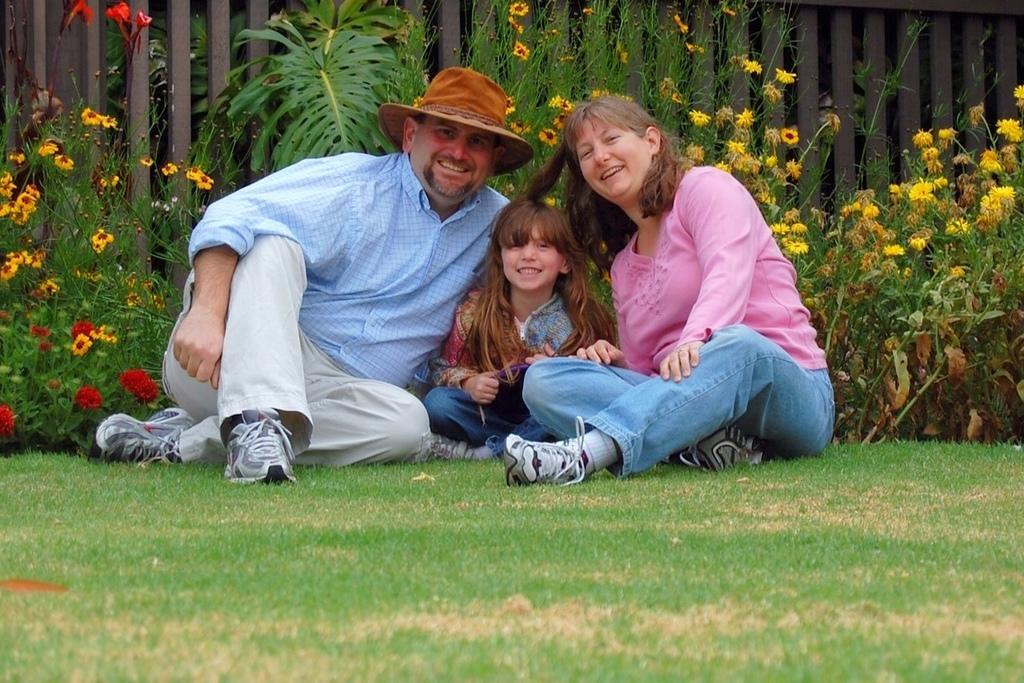In one or two sentences, can you explain what this image depicts? In this picture there are three persons sitting on the grass and smiling. At the back there are different types of flowers on the plants and there is a railing. At the bottom there is grass. 